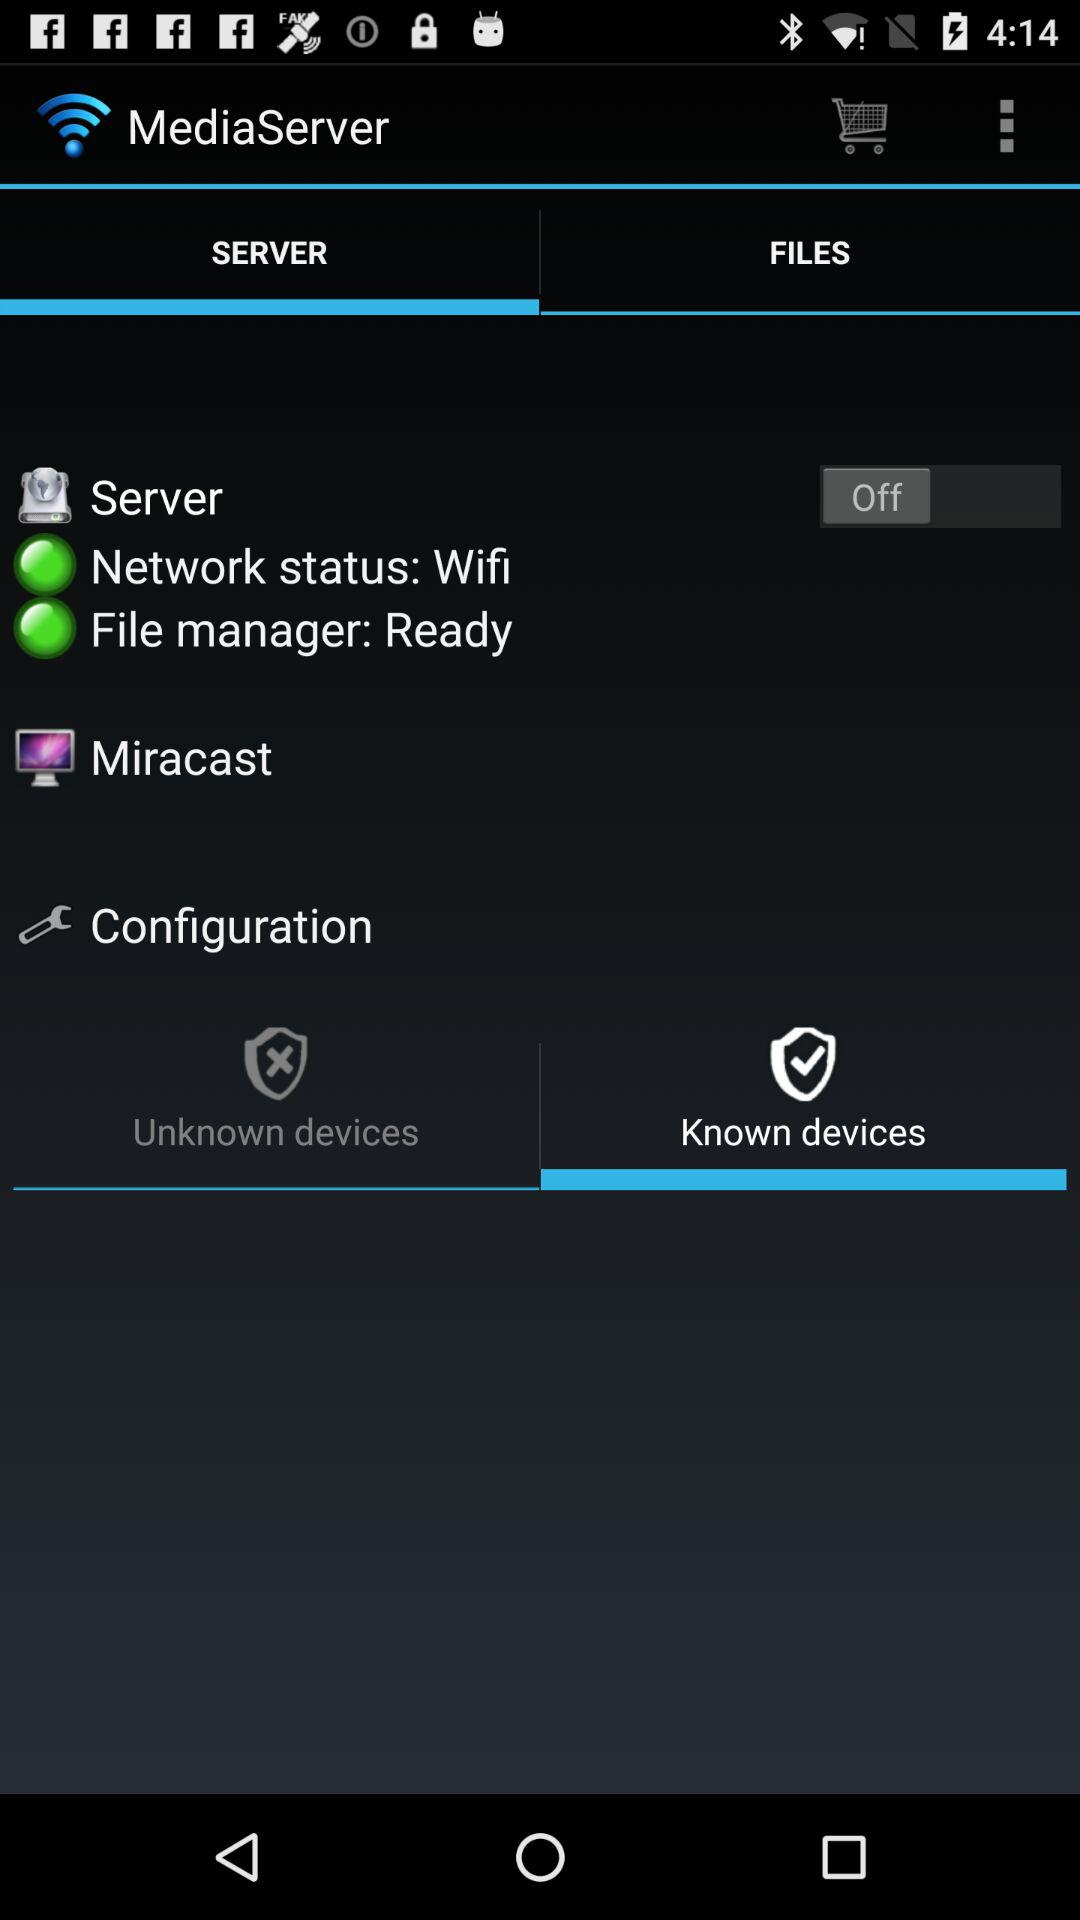Are there any unknown devices connected to the server?
When the provided information is insufficient, respond with <no answer>. <no answer> 